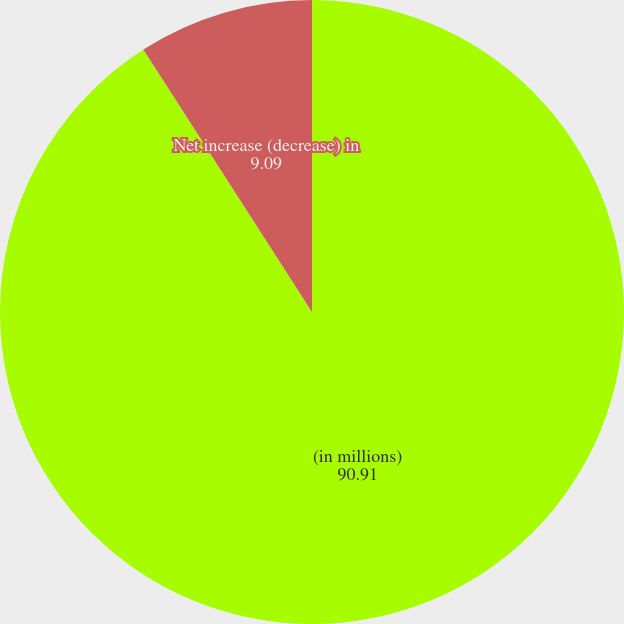<chart> <loc_0><loc_0><loc_500><loc_500><pie_chart><fcel>(in millions)<fcel>Increase (decrease) due to<fcel>Net increase (decrease) in<nl><fcel>90.91%<fcel>0.0%<fcel>9.09%<nl></chart> 